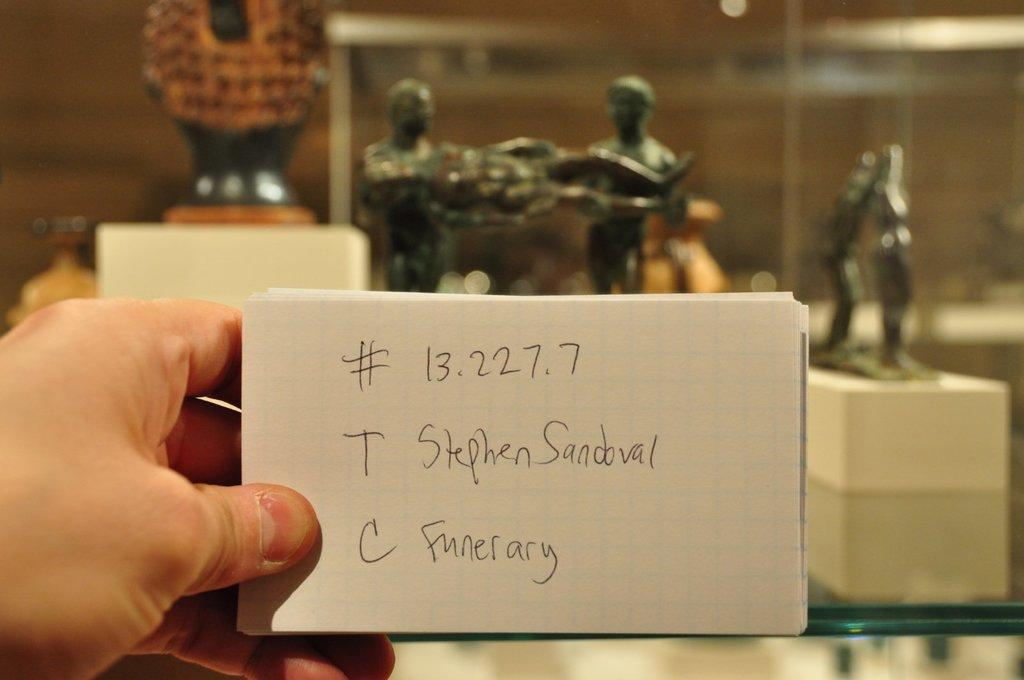What is the main subject of the image? There is a person in the image. What is the person holding in their hand? The person is holding papers in their hand. Can you describe the papers? The papers have text on them. What can be seen in the background of the image? There are statues in the background of the image. What type of knife is being used as a punishment in the image? There is no knife or punishment present in the image. 